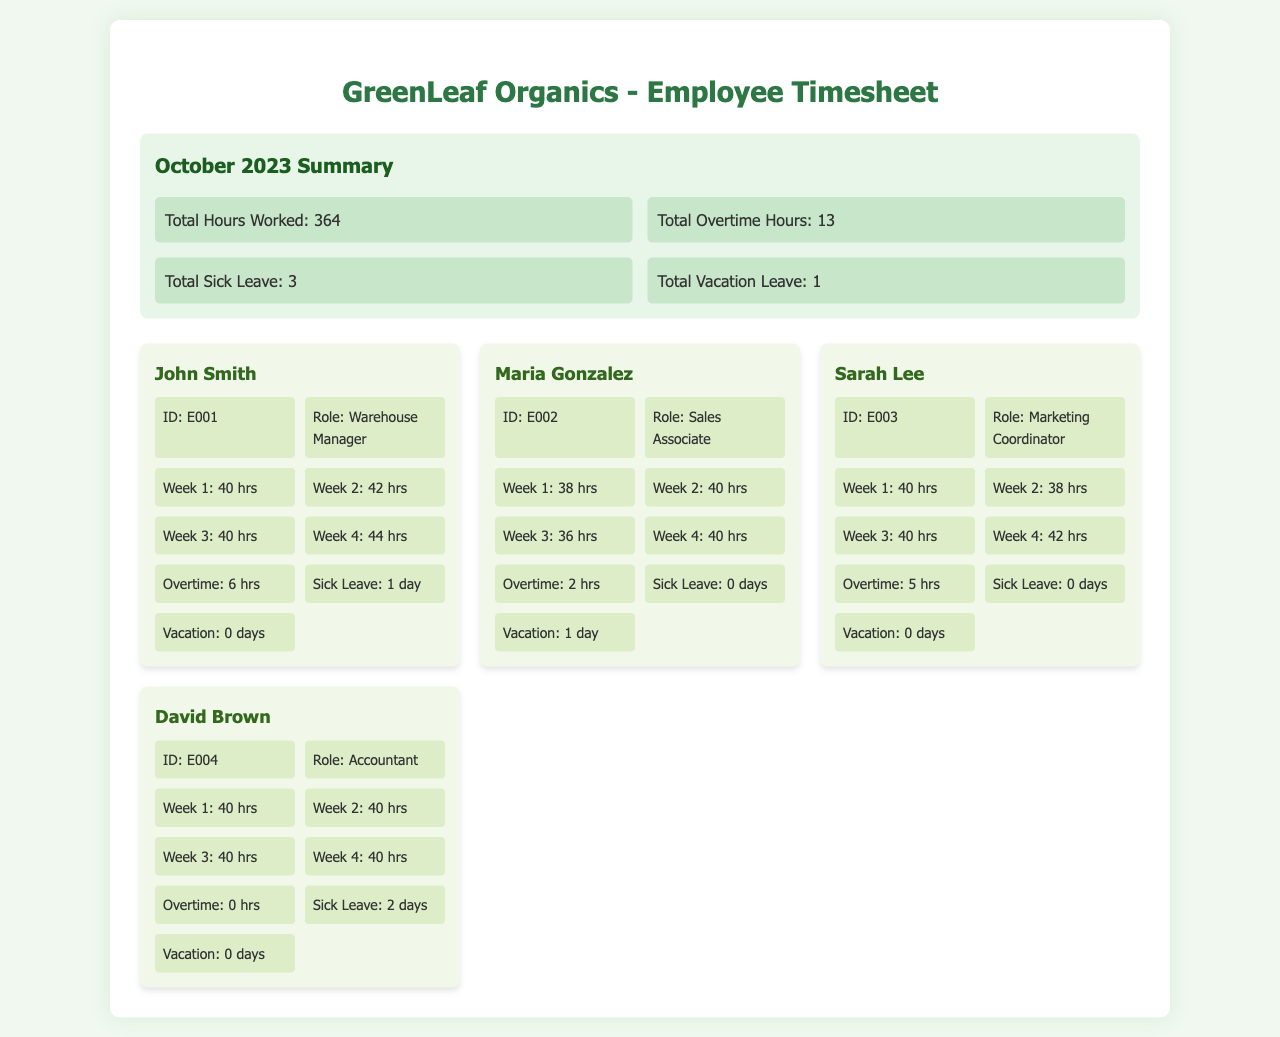What is the total number of hours worked in October 2023? The total hours worked is explicitly stated in the summary section of the document as the cumulative hours from all employees.
Answer: 364 How many total sick leave days were taken? The total sick leave is summarized as a collective value in the summary section, representing all employee absences due to illness.
Answer: 3 What is the name of the Warehouse Manager? The name of the Warehouse Manager is presented with the employee details for John Smith in the employee section.
Answer: John Smith How many hours of overtime did Sarah Lee work? Sarah Lee's total overtime hours are provided in her specific employee details.
Answer: 5 What was the vacation leave taken by Maria Gonzalez? Maria Gonzalez's vacation leave days are listed in her employee details, indicating how many days she took off.
Answer: 1 Who worked the most overtime hours? This question requires comparing the overtime hours across all employees' details to find the one with the highest total.
Answer: John Smith How many hours did David Brown work in Week 2? David Brown's hours worked in Week 2 are listed under his employee details, detailing his weekly hours.
Answer: 40 hrs What is the role of Maria Gonzalez? The role of Maria Gonzalez is mentioned in her employee details section, providing insight into her position in the company.
Answer: Sales Associate What are the total hours worked in Week 4 by all employees combined? To calculate the total hours worked in Week 4, one would need to sum the hours reported for each employee for that week.
Answer: 162 hrs 